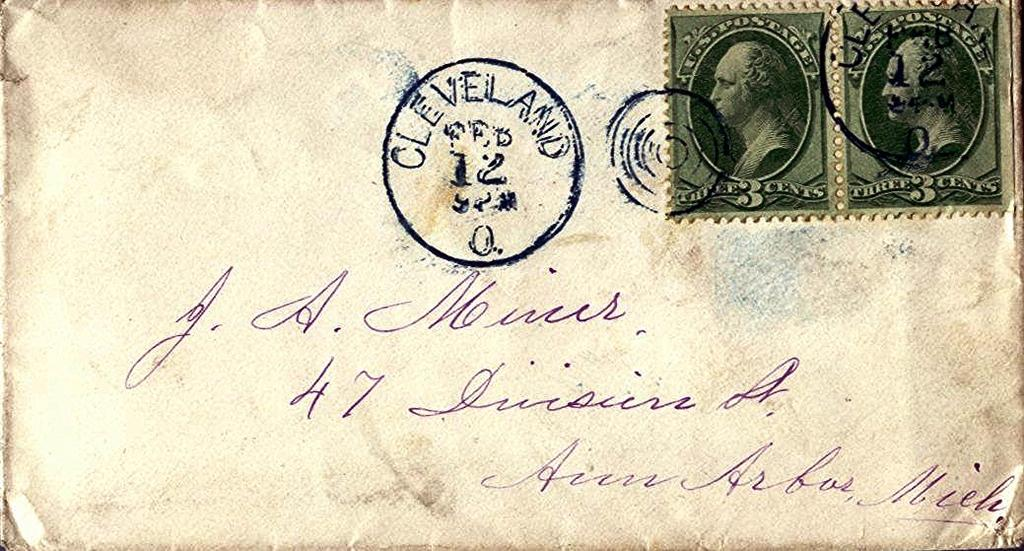What is present on the paper in the image? There are two stamps on the paper in the image. Can you describe the paper in the image? The paper in the image has two stamps on it. What is the weight of the oil in the image? There is no oil present in the image, so it is not possible to determine its weight. 